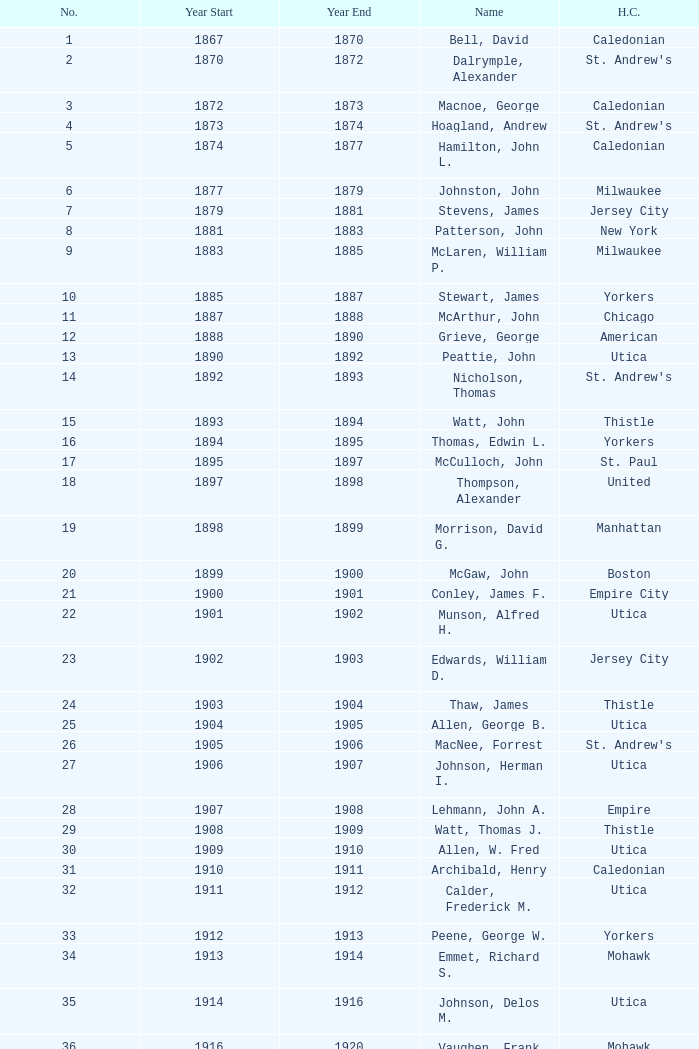Which Number has a Name of cooper, c. kenneth, and a Year End larger than 1984? None. 